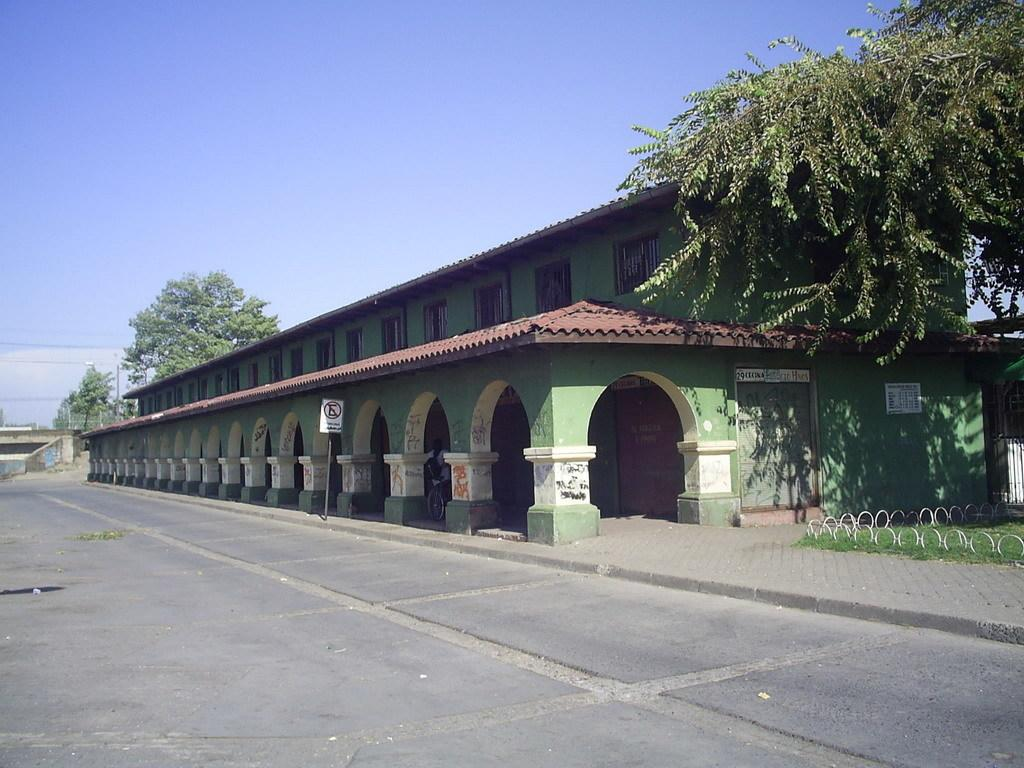What type of structure is present in the image? There is a building in the image. What other natural elements can be seen in the image? There are trees in the image. What is the purpose of the road in front of the building? The road in front of the building is likely for transportation purposes. What can be seen in the background of the image? The sky is visible in the background of the image. Where are the bikes kept in the image? There are no bikes present in the image. Can you tell me how many animals are in the zoo in the image? There is no zoo present in the image. 